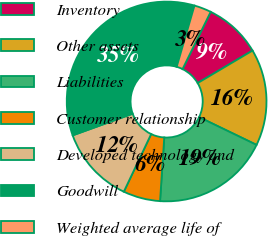Convert chart. <chart><loc_0><loc_0><loc_500><loc_500><pie_chart><fcel>Inventory<fcel>Other assets<fcel>Liabilities<fcel>Customer relationship<fcel>Developed technology and<fcel>Goodwill<fcel>Weighted average life of<nl><fcel>9.22%<fcel>15.67%<fcel>18.89%<fcel>6.0%<fcel>12.44%<fcel>35.01%<fcel>2.77%<nl></chart> 